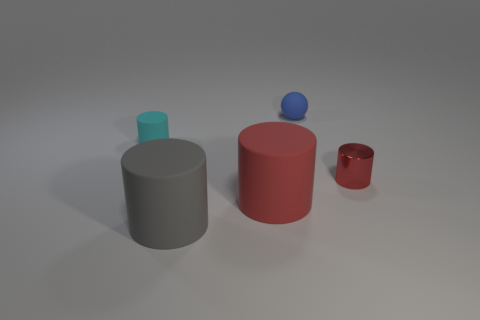Add 3 small rubber balls. How many objects exist? 8 Subtract all cylinders. How many objects are left? 1 Subtract 0 cyan balls. How many objects are left? 5 Subtract all large gray cubes. Subtract all big red rubber cylinders. How many objects are left? 4 Add 5 red rubber cylinders. How many red rubber cylinders are left? 6 Add 4 purple matte objects. How many purple matte objects exist? 4 